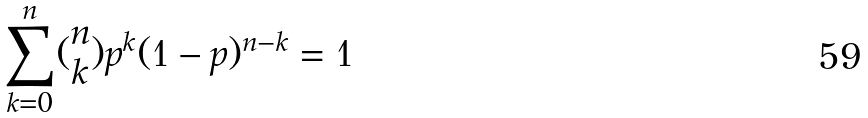<formula> <loc_0><loc_0><loc_500><loc_500>\sum _ { k = 0 } ^ { n } ( \begin{matrix} n \\ k \end{matrix} ) p ^ { k } ( 1 - p ) ^ { n - k } = 1</formula> 